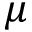Convert formula to latex. <formula><loc_0><loc_0><loc_500><loc_500>\mu</formula> 